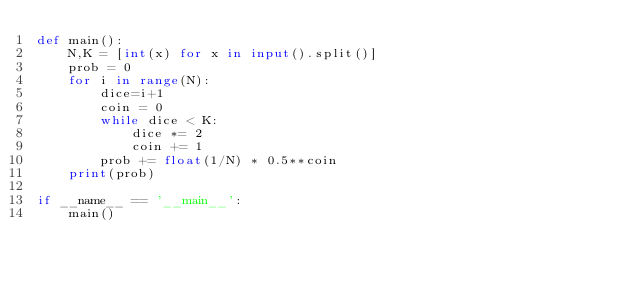<code> <loc_0><loc_0><loc_500><loc_500><_Python_>def main():
    N,K = [int(x) for x in input().split()]
    prob = 0
    for i in range(N):
        dice=i+1
        coin = 0
        while dice < K:
            dice *= 2
            coin += 1
        prob += float(1/N) * 0.5**coin
    print(prob)

if __name__ == '__main__':
    main()</code> 